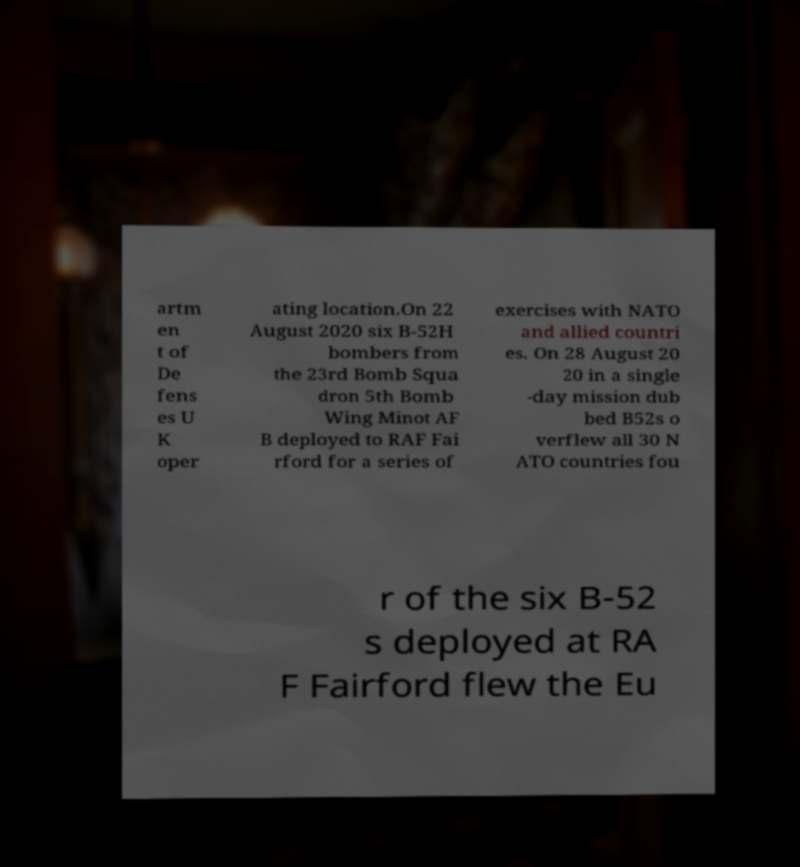I need the written content from this picture converted into text. Can you do that? artm en t of De fens es U K oper ating location.On 22 August 2020 six B-52H bombers from the 23rd Bomb Squa dron 5th Bomb Wing Minot AF B deployed to RAF Fai rford for a series of exercises with NATO and allied countri es. On 28 August 20 20 in a single -day mission dub bed B52s o verflew all 30 N ATO countries fou r of the six B-52 s deployed at RA F Fairford flew the Eu 